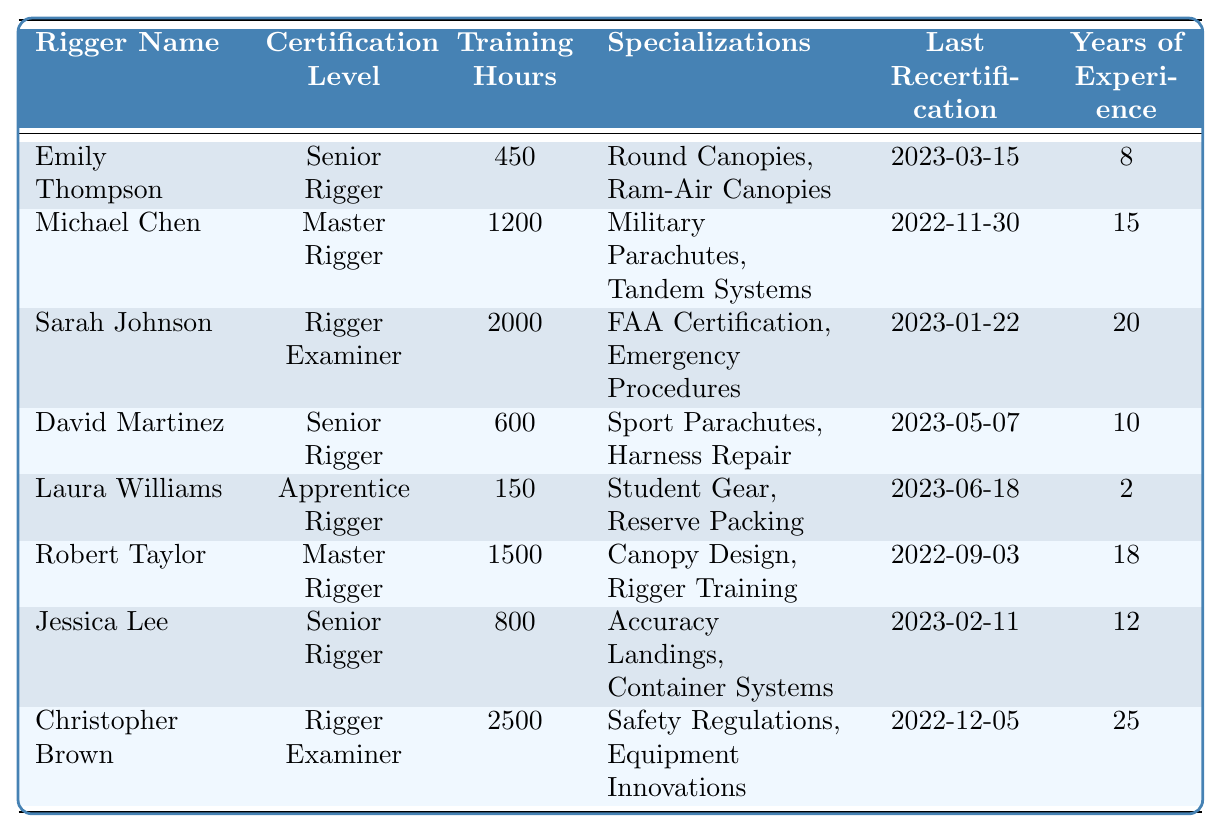What is the certification level of David Martinez? The table lists David Martinez under the "Certification Level" column, and it shows "Senior Rigger."
Answer: Senior Rigger How many training hours has Sarah Johnson completed? By checking the "Training Hours" column for Sarah Johnson, it states 2000 hours.
Answer: 2000 Which rigger has the most years of experience? Looking through the "Years of Experience" column, Christopher Brown has 25 years, which is more than the others.
Answer: 25 What specializations does Emily Thompson have? In the "Specializations" column, Emily Thompson's specializations are listed as "Round Canopies, Ram-Air Canopies."
Answer: Round Canopies, Ram-Air Canopies Is Jessica Lee's last recertification date more recent than Michael Chen's? Jessica Lee's last recertification date is 2023-02-11, and Michael Chen's is 2022-11-30. Since 2023 is after 2022, her date is more recent.
Answer: Yes Calculate the average training hours among all riggers. The total training hours are 450 + 1200 + 2000 + 600 + 150 + 1500 + 800 + 2500 = 8200 hours. There are 8 riggers, so the average is 8200/8 = 1025.
Answer: 1025 How many riggers are at the "Master Rigger" certification level? The certification levels for the riggers are checked, and both Michael Chen and Robert Taylor are listed as "Master Rigger," so there are two.
Answer: 2 Has Laura Williams completed more or less than 300 training hours? Laura Williams has 150 training hours, which is less than 300.
Answer: Less What is the last recertification date for Robert Taylor? In the "Last Recertification" column, Robert Taylor's date is noted as 2022-09-03.
Answer: 2022-09-03 Which rigger has a specialization in "Safety Regulations"? By referring to the "Specializations" column, Christopher Brown is identified with "Safety Regulations" as one of his specializations.
Answer: Christopher Brown 